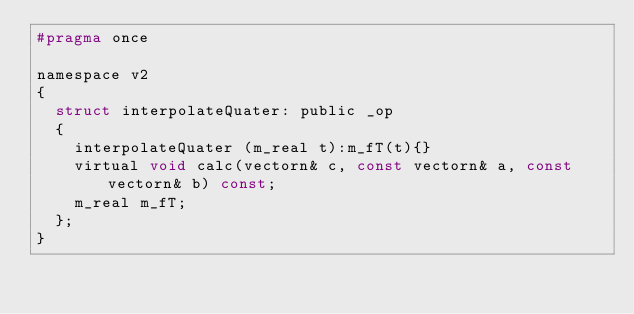<code> <loc_0><loc_0><loc_500><loc_500><_C_>#pragma once

namespace v2
{
	struct interpolateQuater: public _op
	{
		interpolateQuater (m_real t):m_fT(t){}
		virtual void calc(vectorn& c, const vectorn& a, const vectorn& b) const;
		m_real m_fT;
	};
}
</code> 